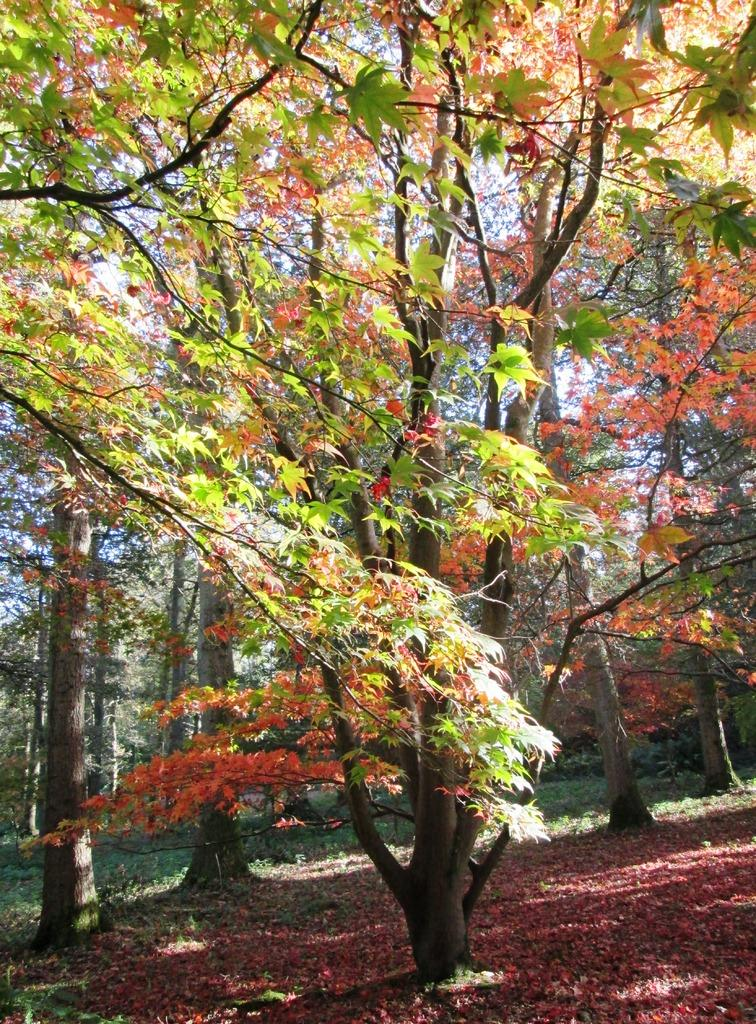What type of vegetation can be seen in the image? There are trees, plants, and grass visible in the image. What part of the natural environment is present in the image? The natural environment includes trees, plants, grass, and the sky. What is visible in the background of the image? The sky is visible in the background of the image. What type of cream can be seen on the trees in the image? There is no cream present on the trees in the image; they are simply trees with leaves and branches. 